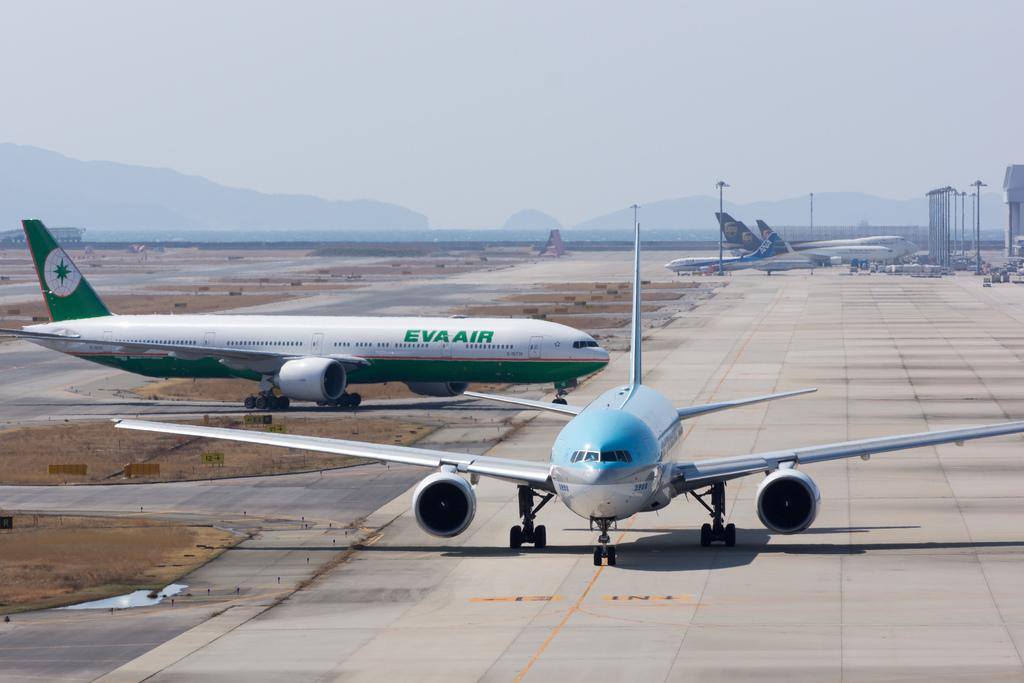<image>
Render a clear and concise summary of the photo. Two air planes on a run way, one of which is green with Eva Air written on the side. 